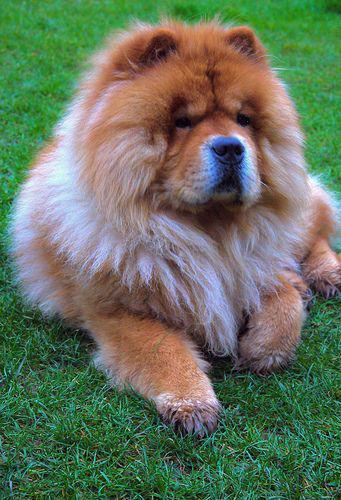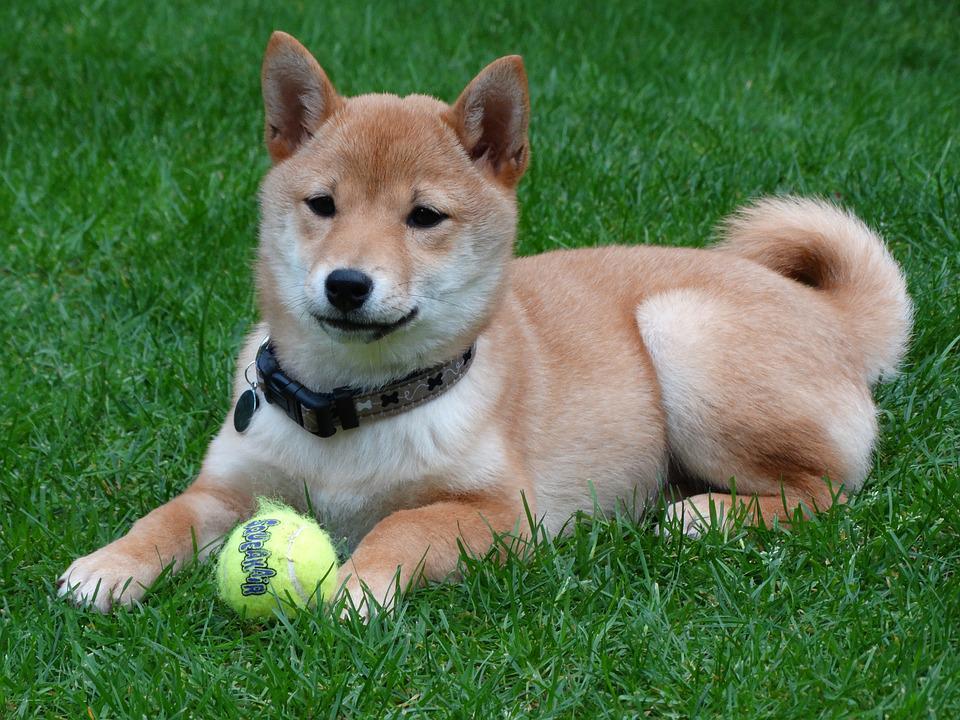The first image is the image on the left, the second image is the image on the right. For the images displayed, is the sentence "The dog in the image on the left is standing." factually correct? Answer yes or no. No. The first image is the image on the left, the second image is the image on the right. Considering the images on both sides, is "Right image features one dog, which is reclining with front paws forward." valid? Answer yes or no. Yes. 